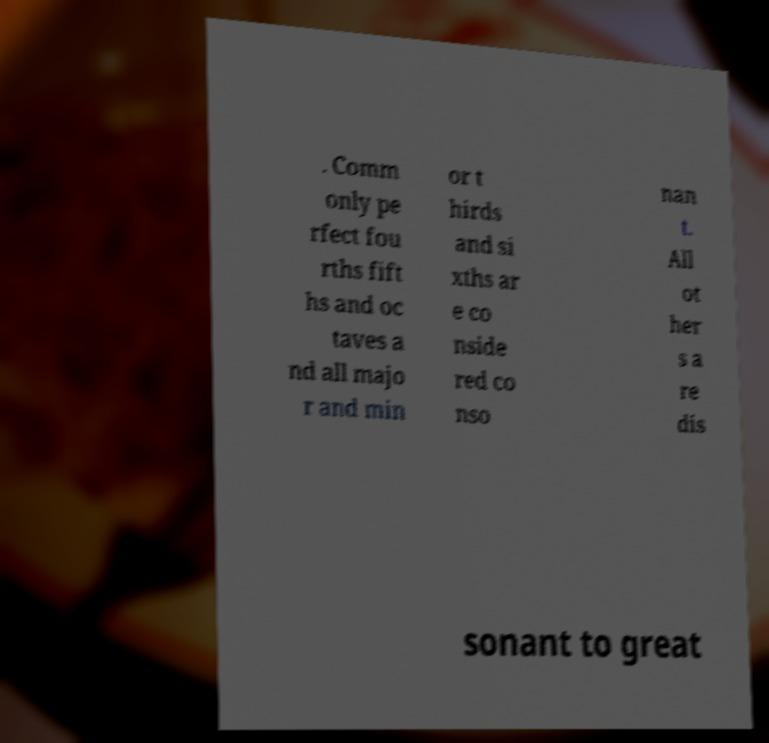Could you extract and type out the text from this image? . Comm only pe rfect fou rths fift hs and oc taves a nd all majo r and min or t hirds and si xths ar e co nside red co nso nan t. All ot her s a re dis sonant to great 